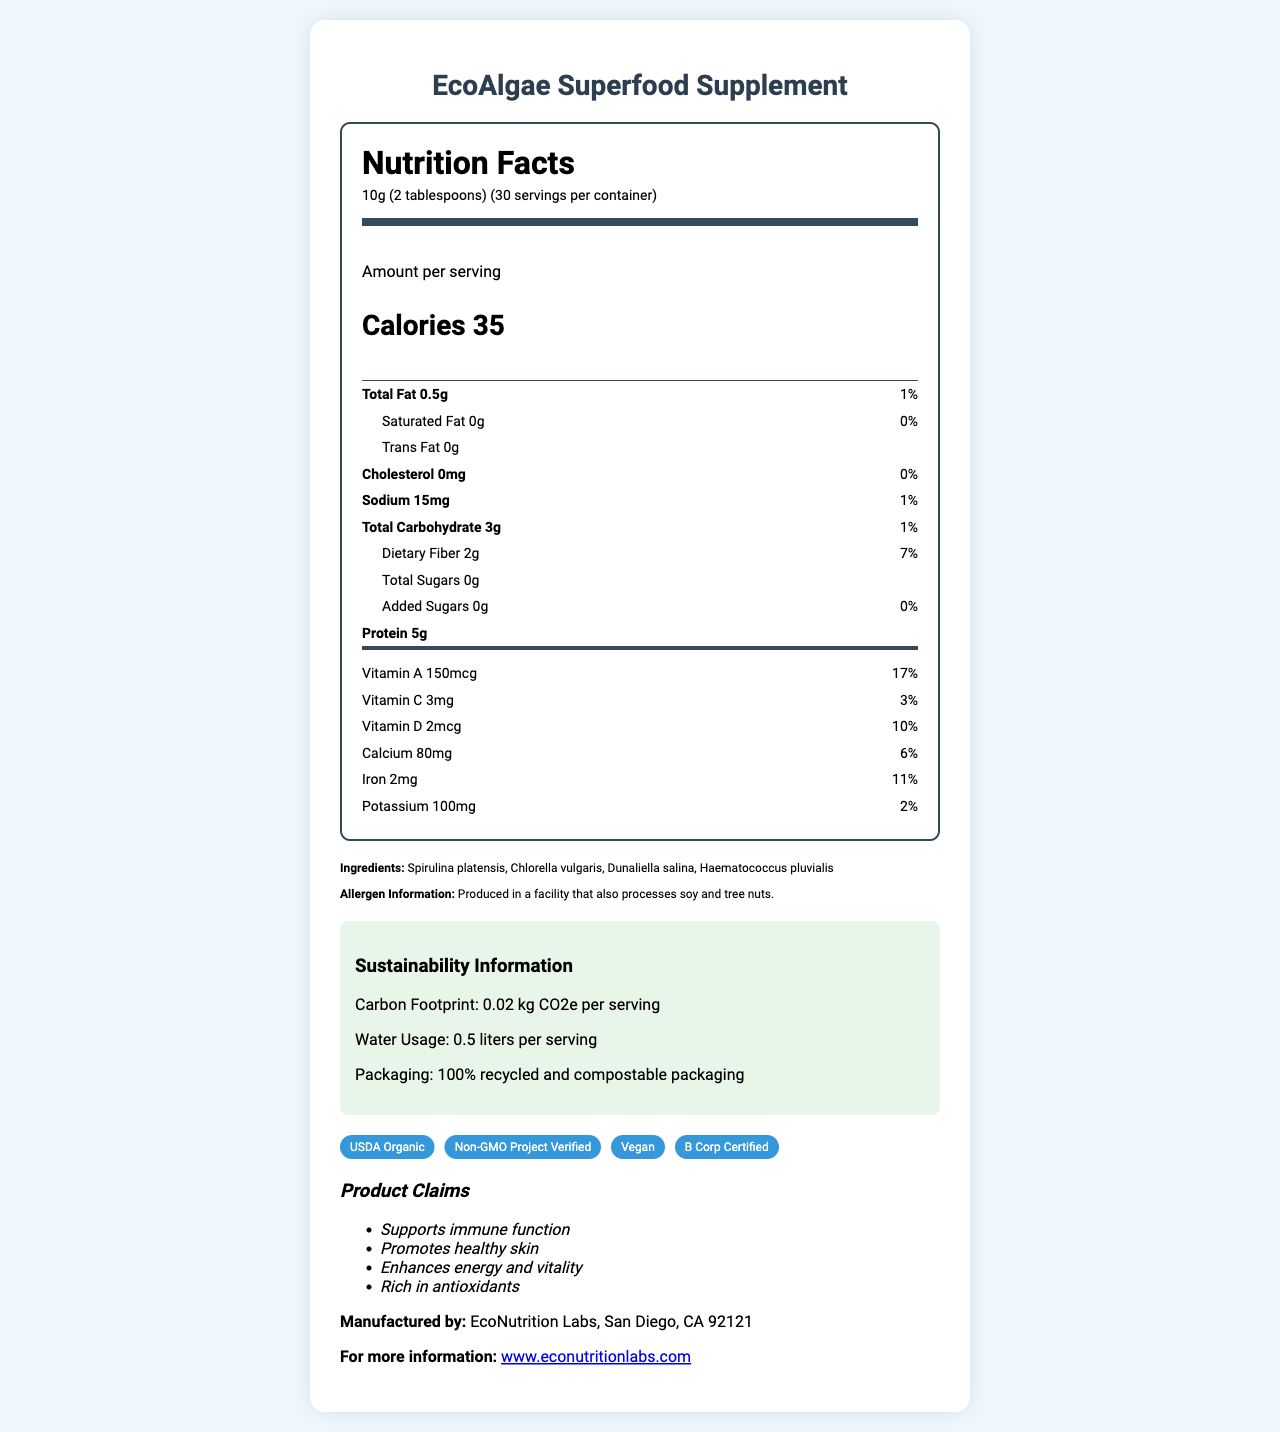what is the serving size of the EcoAlgae Superfood Supplement? The serving size is specified clearly on the document as 10g (2 tablespoons).
Answer: 10g (2 tablespoons) how many calories are in one serving of the EcoAlgae Superfood Supplement? The document lists the calories per serving as 35.
Answer: 35 which ingredient in the EcoAlgae Superfood Supplement is NOT part of it? A. Spirulina platensis B. Chlorella vulgaris C. Ulva lactuca D. Dunaliella salina The listed ingredients include Spirulina platensis, Chlorella vulgaris, and Dunaliella salina, but not Ulva lactuca.
Answer: C. Ulva lactuca what percentage of the daily value of Vitamin A does one serving contain? The daily value percentage for Vitamin A is shown as 17%.
Answer: 17% does the EcoAlgae Superfood Supplement contain any added sugars? Yes/No The document indicates that the amount of added sugars is 0g which corresponds to 0% of the daily value.
Answer: No summarize the main idea of the document. The document elaborates extensively on the nutrition facts, sustainability aspects, and certifications to help consumers understand the benefits and composition of the product.
Answer: The document provides the nutrition facts and other relevant information about the EcoAlgae Superfood Supplement, an algae-based, sustainable food supplement. It contains nutritional details, ingredient list, allergen information, sustainability metrics, certifications, and product claims. what is the manufacturer of the EcoAlgae Superfood Supplement? The manufacturer's information is listed as EcoNutrition Labs, located in San Diego, CA.
Answer: EcoNutrition Labs how many servings are there per container? The document states that there are 30 servings per container.
Answer: 30 which of the following certifications does the EcoAlgae Superfood Supplement NOT have? I. USDA Organic II. Non-GMO Project Verified III. Fair Trade IV. B Corp Certified The certifications listed include USDA Organic, Non-GMO Project Verified, and B Corp Certified but not Fair Trade.
Answer: III. Fair Trade how much protein is in one serving of the EcoAlgae Superfood Supplement? The document states that there is 5 grams of protein per serving.
Answer: 5g what is the total amount of carbohydrates in one serving? The total carbohydrate content per serving is listed as 3g.
Answer: 3g can you consume this product if you are allergic to soy? The allergen information indicates that the product is produced in a facility that also processes soy.
Answer: No explain the sustainability features of the EcoAlgae Superfood Supplement. The document highlights these sustainability metrics to emphasize the environmentally friendly nature of the product.
Answer: The EcoAlgae Superfood Supplement has a low carbon footprint of 0.02 kg CO2e per serving, uses only 0.5 liters of water per serving, and its packaging is 100% recycled and compostable. how much sodium is in a single serving, and what is its daily value percentage? The sodium content per serving is 15mg, which is 1% of the daily value.
Answer: 15mg, 1% does the product make any claims about promoting healthy skin? One of the product claims listed is "Promotes healthy skin."
Answer: Yes who is the manufacturer and where are they located? The manufacturer mentioned is EcoNutrition Labs, located in San Diego, CA 92121.
Answer: EcoNutrition Labs, San Diego, CA 92121 how can you contact the manufacturer for more information? The document provides the website www.econutritionlabs.com for more information.
Answer: By visiting their website at www.econutritionlabs.com which vitamins and minerals are provided by the EcoAlgae Superfood Supplement? The document lists the amounts and daily values of Vitamin A, Vitamin C, Vitamin D, Calcium, Iron, and Potassium per serving.
Answer: Vitamin A, Vitamin C, Vitamin D, Calcium, Iron, and Potassium how much water is used per serving of the EcoAlgae Superfood Supplement? The sustainability information states that 0.5 liters of water is used per serving.
Answer: 0.5 liters who is the primary target audience for the EcoAlgae Superfood Supplement based on the claims? Based on the product claims, it is targeted at individuals interested in health benefits like immune support, healthy skin, and antioxidants.
Answer: Health-conscious individuals looking for immune support, healthy skin, energy, vitality, and antioxidants 